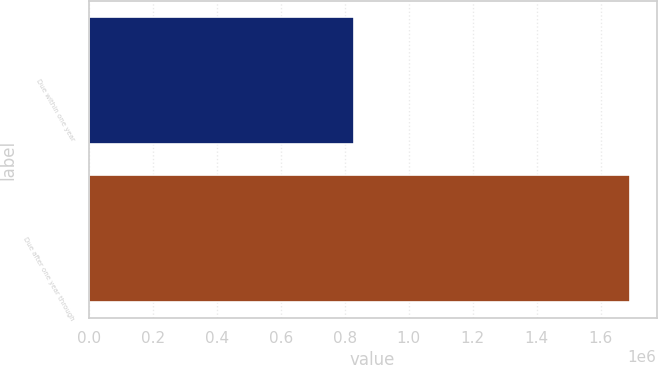Convert chart. <chart><loc_0><loc_0><loc_500><loc_500><bar_chart><fcel>Due within one year<fcel>Due after one year through<nl><fcel>827823<fcel>1.68975e+06<nl></chart> 